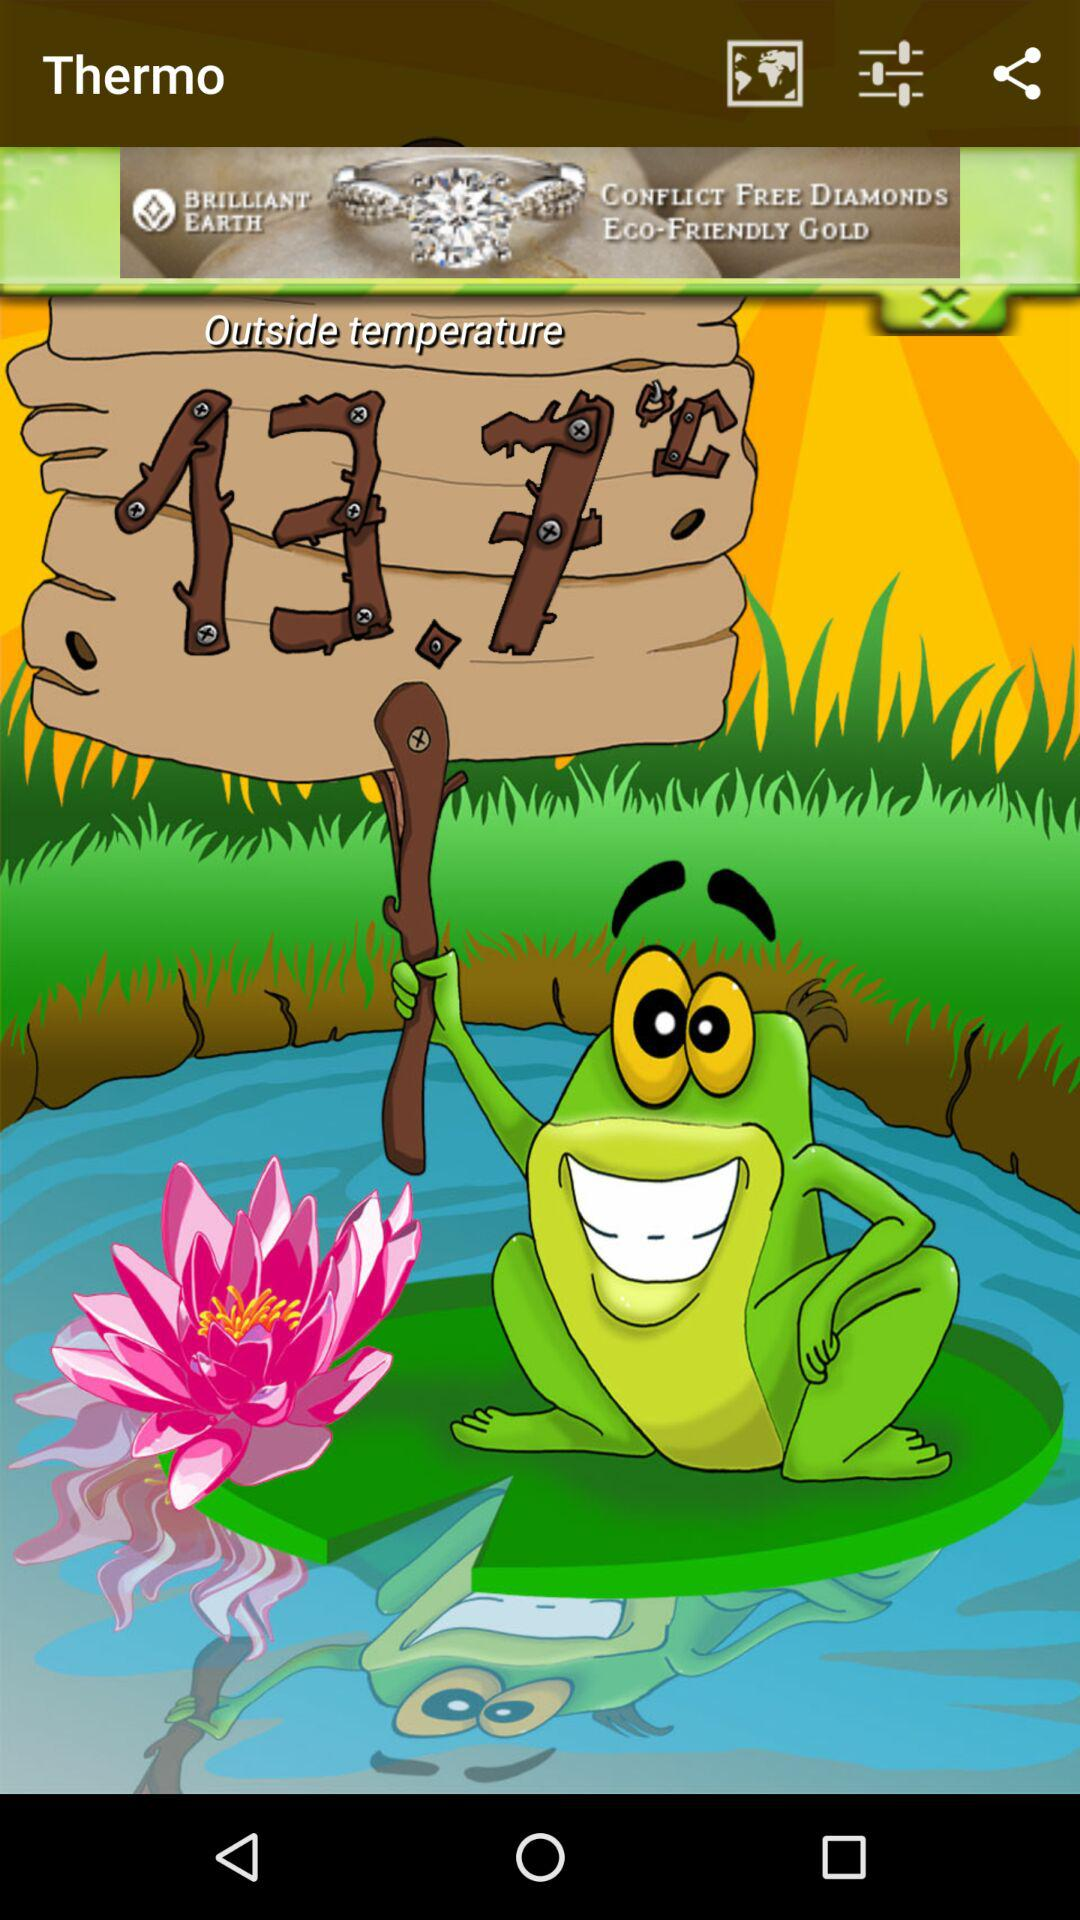What is the outside temperature? The outside temperature is 13.7 °C. 